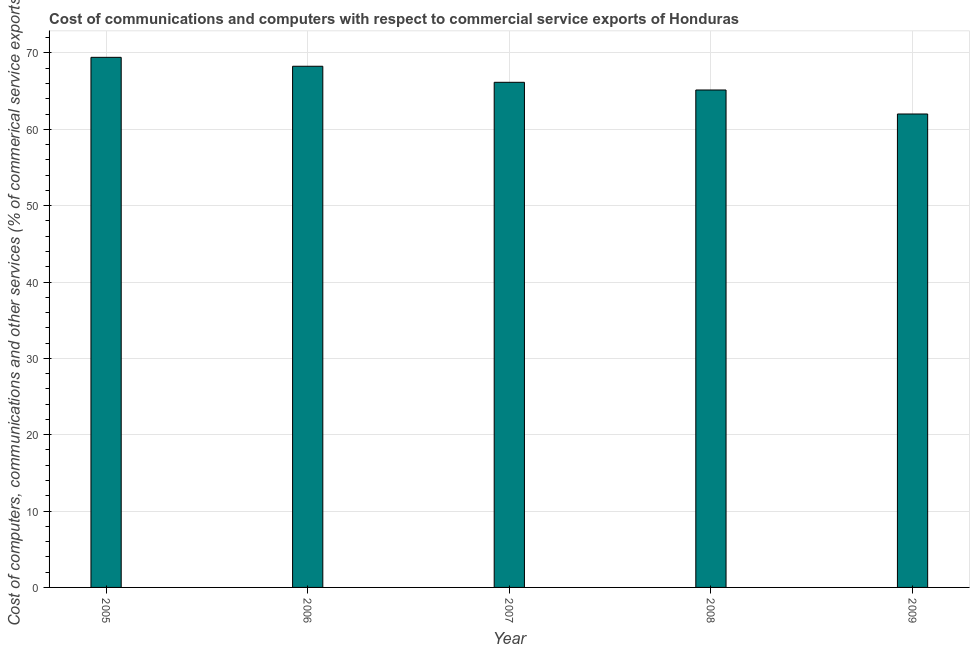Does the graph contain any zero values?
Your answer should be compact. No. Does the graph contain grids?
Offer a very short reply. Yes. What is the title of the graph?
Your answer should be very brief. Cost of communications and computers with respect to commercial service exports of Honduras. What is the label or title of the X-axis?
Your answer should be very brief. Year. What is the label or title of the Y-axis?
Offer a very short reply. Cost of computers, communications and other services (% of commerical service exports). What is the  computer and other services in 2005?
Make the answer very short. 69.43. Across all years, what is the maximum cost of communications?
Make the answer very short. 69.43. Across all years, what is the minimum  computer and other services?
Make the answer very short. 62. In which year was the cost of communications minimum?
Provide a succinct answer. 2009. What is the sum of the  computer and other services?
Your answer should be very brief. 331. What is the difference between the cost of communications in 2008 and 2009?
Your response must be concise. 3.14. What is the average cost of communications per year?
Ensure brevity in your answer.  66.2. What is the median cost of communications?
Keep it short and to the point. 66.16. What is the ratio of the cost of communications in 2006 to that in 2008?
Keep it short and to the point. 1.05. What is the difference between the highest and the second highest cost of communications?
Your answer should be compact. 1.17. What is the difference between the highest and the lowest  computer and other services?
Provide a short and direct response. 7.42. In how many years, is the cost of communications greater than the average cost of communications taken over all years?
Ensure brevity in your answer.  2. How many bars are there?
Offer a very short reply. 5. How many years are there in the graph?
Offer a terse response. 5. What is the Cost of computers, communications and other services (% of commerical service exports) of 2005?
Offer a terse response. 69.43. What is the Cost of computers, communications and other services (% of commerical service exports) of 2006?
Make the answer very short. 68.26. What is the Cost of computers, communications and other services (% of commerical service exports) in 2007?
Ensure brevity in your answer.  66.16. What is the Cost of computers, communications and other services (% of commerical service exports) in 2008?
Your response must be concise. 65.15. What is the Cost of computers, communications and other services (% of commerical service exports) in 2009?
Offer a terse response. 62. What is the difference between the Cost of computers, communications and other services (% of commerical service exports) in 2005 and 2006?
Ensure brevity in your answer.  1.17. What is the difference between the Cost of computers, communications and other services (% of commerical service exports) in 2005 and 2007?
Offer a terse response. 3.27. What is the difference between the Cost of computers, communications and other services (% of commerical service exports) in 2005 and 2008?
Your answer should be compact. 4.28. What is the difference between the Cost of computers, communications and other services (% of commerical service exports) in 2005 and 2009?
Ensure brevity in your answer.  7.42. What is the difference between the Cost of computers, communications and other services (% of commerical service exports) in 2006 and 2007?
Your response must be concise. 2.1. What is the difference between the Cost of computers, communications and other services (% of commerical service exports) in 2006 and 2008?
Give a very brief answer. 3.11. What is the difference between the Cost of computers, communications and other services (% of commerical service exports) in 2006 and 2009?
Make the answer very short. 6.25. What is the difference between the Cost of computers, communications and other services (% of commerical service exports) in 2007 and 2008?
Your answer should be very brief. 1.01. What is the difference between the Cost of computers, communications and other services (% of commerical service exports) in 2007 and 2009?
Your answer should be very brief. 4.15. What is the difference between the Cost of computers, communications and other services (% of commerical service exports) in 2008 and 2009?
Your answer should be compact. 3.14. What is the ratio of the Cost of computers, communications and other services (% of commerical service exports) in 2005 to that in 2006?
Offer a very short reply. 1.02. What is the ratio of the Cost of computers, communications and other services (% of commerical service exports) in 2005 to that in 2007?
Offer a terse response. 1.05. What is the ratio of the Cost of computers, communications and other services (% of commerical service exports) in 2005 to that in 2008?
Ensure brevity in your answer.  1.07. What is the ratio of the Cost of computers, communications and other services (% of commerical service exports) in 2005 to that in 2009?
Give a very brief answer. 1.12. What is the ratio of the Cost of computers, communications and other services (% of commerical service exports) in 2006 to that in 2007?
Provide a succinct answer. 1.03. What is the ratio of the Cost of computers, communications and other services (% of commerical service exports) in 2006 to that in 2008?
Your answer should be very brief. 1.05. What is the ratio of the Cost of computers, communications and other services (% of commerical service exports) in 2006 to that in 2009?
Give a very brief answer. 1.1. What is the ratio of the Cost of computers, communications and other services (% of commerical service exports) in 2007 to that in 2009?
Your answer should be compact. 1.07. What is the ratio of the Cost of computers, communications and other services (% of commerical service exports) in 2008 to that in 2009?
Ensure brevity in your answer.  1.05. 